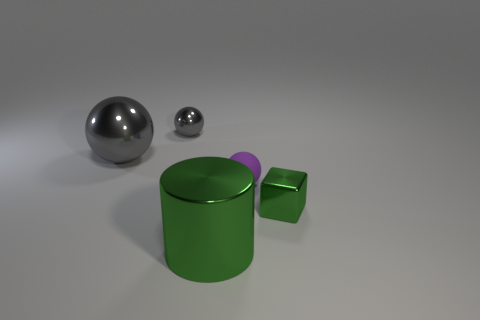Subtract all purple spheres. How many spheres are left? 2 Add 4 small purple matte objects. How many objects exist? 9 Subtract all brown blocks. How many gray balls are left? 2 Subtract all purple balls. How many balls are left? 2 Subtract 1 cylinders. How many cylinders are left? 0 Subtract all balls. How many objects are left? 2 Subtract all tiny objects. Subtract all tiny brown rubber things. How many objects are left? 2 Add 4 tiny gray metallic things. How many tiny gray metallic things are left? 5 Add 4 matte things. How many matte things exist? 5 Subtract 0 red cylinders. How many objects are left? 5 